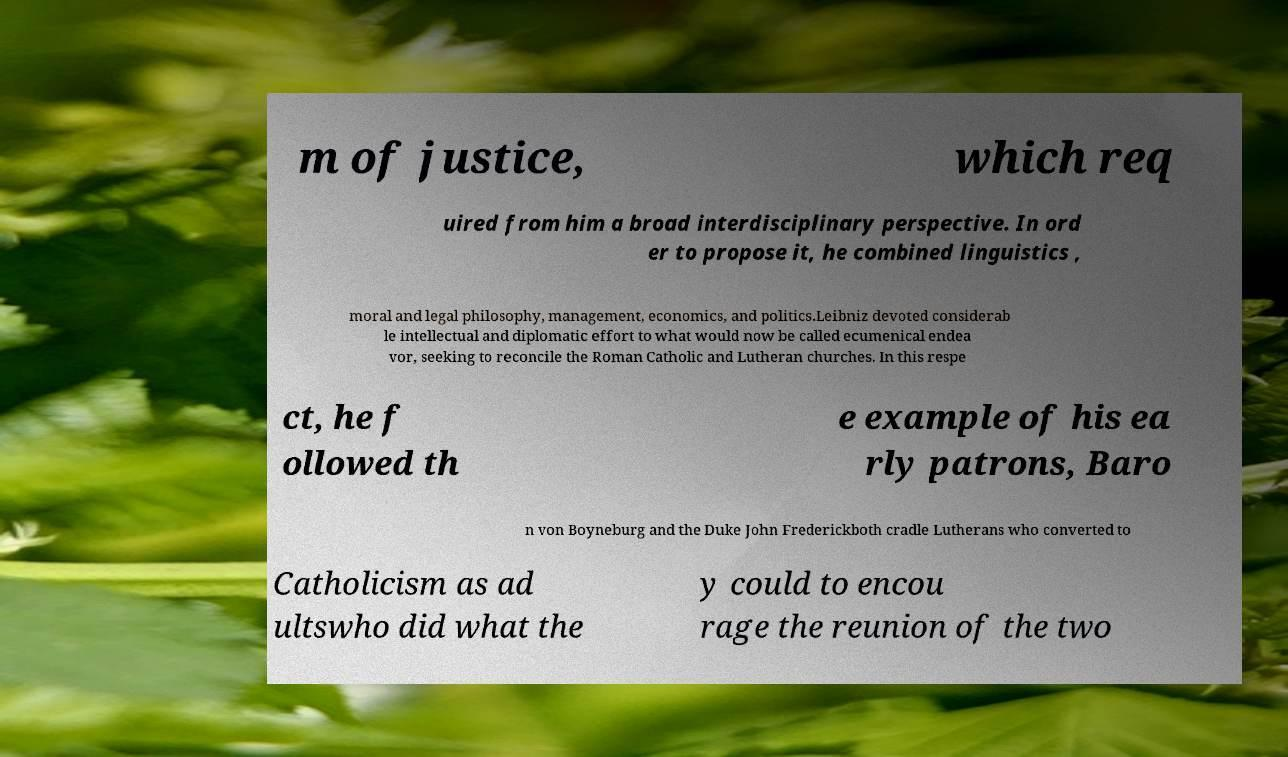There's text embedded in this image that I need extracted. Can you transcribe it verbatim? m of justice, which req uired from him a broad interdisciplinary perspective. In ord er to propose it, he combined linguistics , moral and legal philosophy, management, economics, and politics.Leibniz devoted considerab le intellectual and diplomatic effort to what would now be called ecumenical endea vor, seeking to reconcile the Roman Catholic and Lutheran churches. In this respe ct, he f ollowed th e example of his ea rly patrons, Baro n von Boyneburg and the Duke John Frederickboth cradle Lutherans who converted to Catholicism as ad ultswho did what the y could to encou rage the reunion of the two 